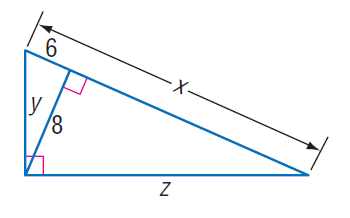Answer the mathemtical geometry problem and directly provide the correct option letter.
Question: Find x.
Choices: A: 2 \sqrt { 6 } B: 4 \sqrt { 6 } C: \frac { 32 } { 3 } D: \frac { 50 } { 3 } D 